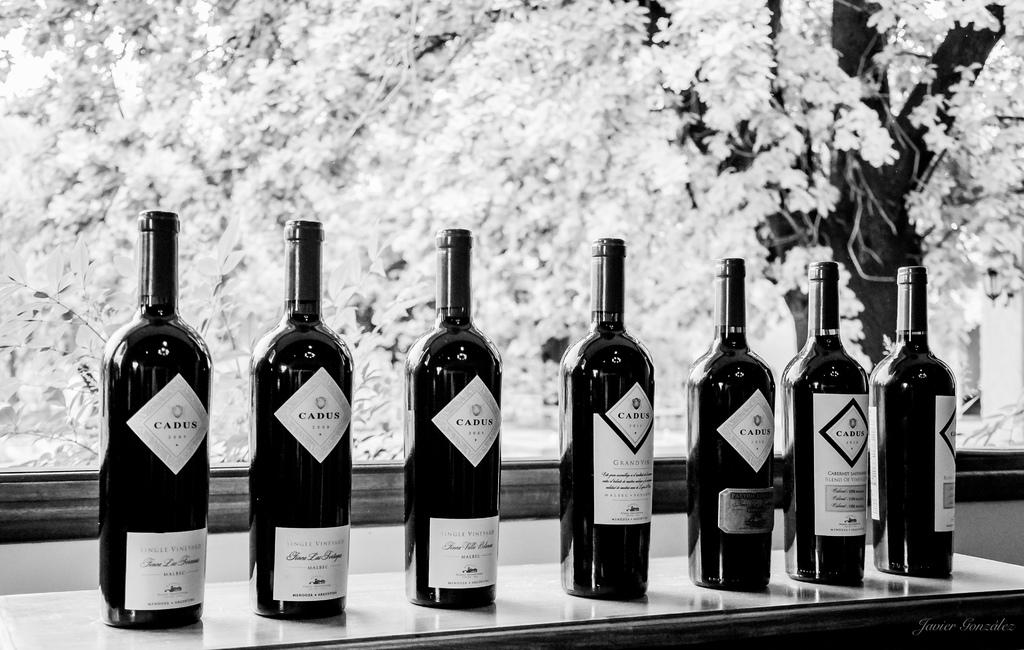<image>
Write a terse but informative summary of the picture. A number of bottles of red wine with the label Cadus. 